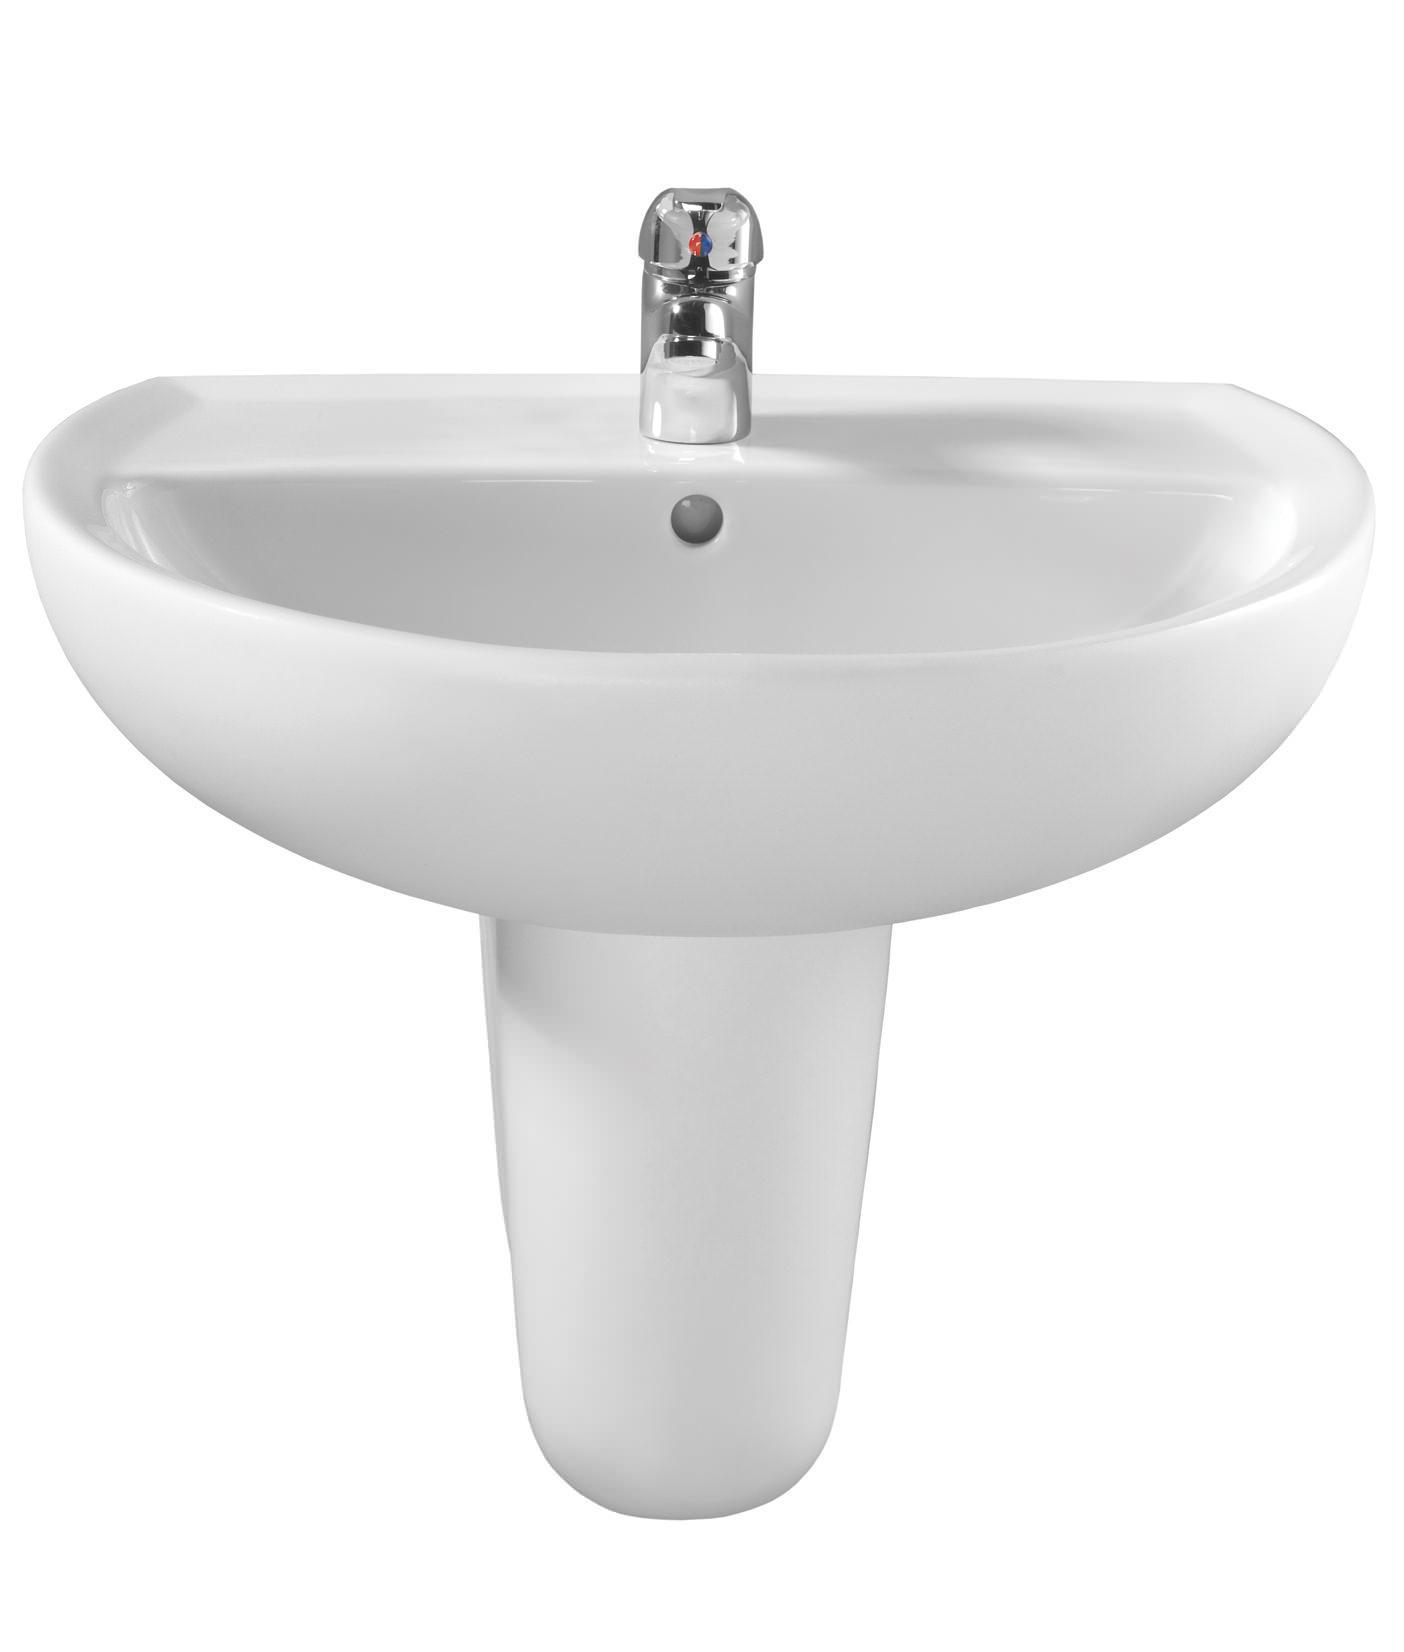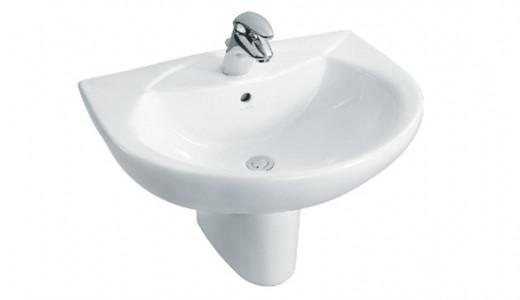The first image is the image on the left, the second image is the image on the right. For the images displayed, is the sentence "The drain in the bottom of the basin is visible in the image on the right." factually correct? Answer yes or no. Yes. 